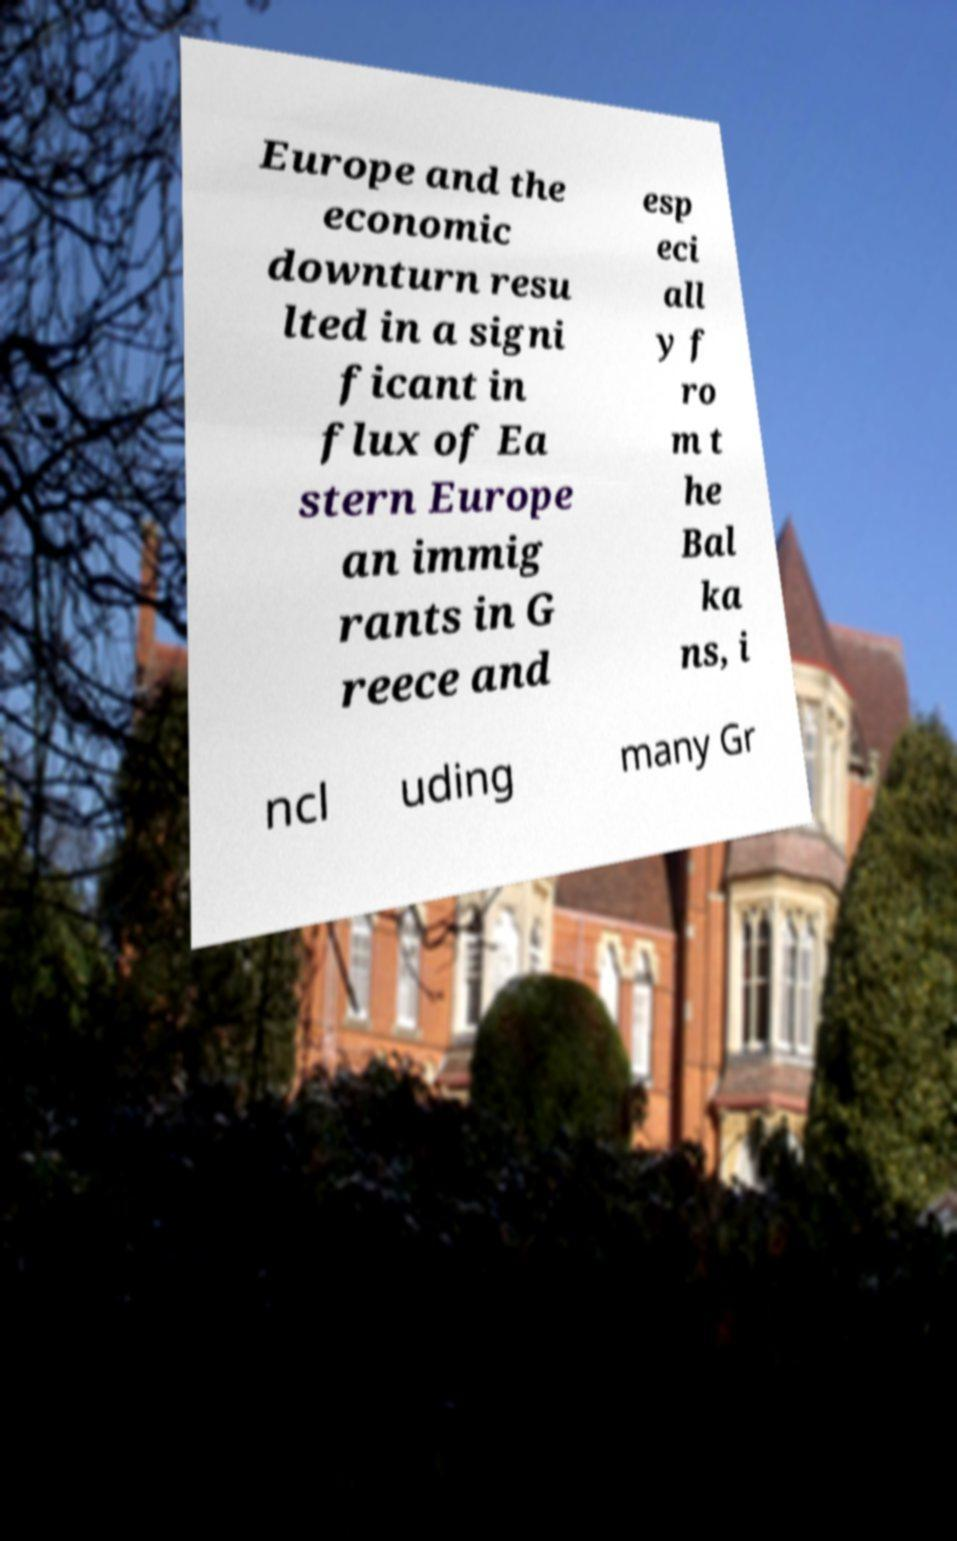Please identify and transcribe the text found in this image. Europe and the economic downturn resu lted in a signi ficant in flux of Ea stern Europe an immig rants in G reece and esp eci all y f ro m t he Bal ka ns, i ncl uding many Gr 